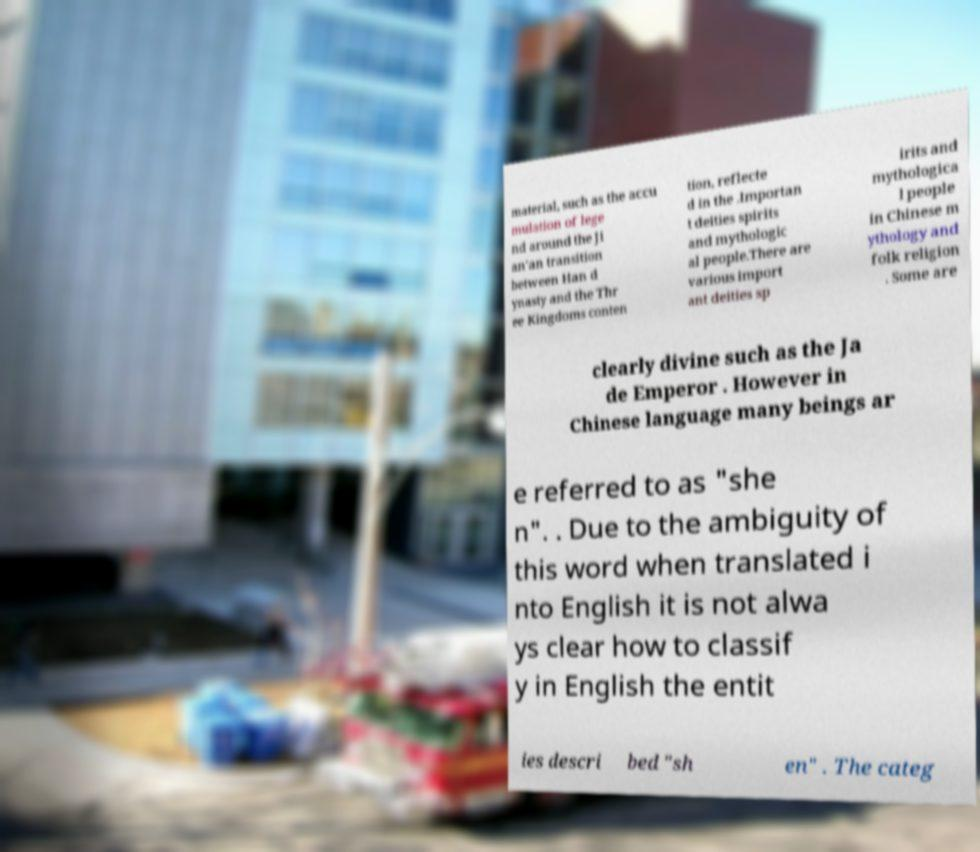Could you assist in decoding the text presented in this image and type it out clearly? material, such as the accu mulation of lege nd around the Ji an'an transition between Han d ynasty and the Thr ee Kingdoms conten tion, reflecte d in the .Importan t deities spirits and mythologic al people.There are various import ant deities sp irits and mythologica l people in Chinese m ythology and folk religion . Some are clearly divine such as the Ja de Emperor . However in Chinese language many beings ar e referred to as "she n". . Due to the ambiguity of this word when translated i nto English it is not alwa ys clear how to classif y in English the entit ies descri bed "sh en" . The categ 